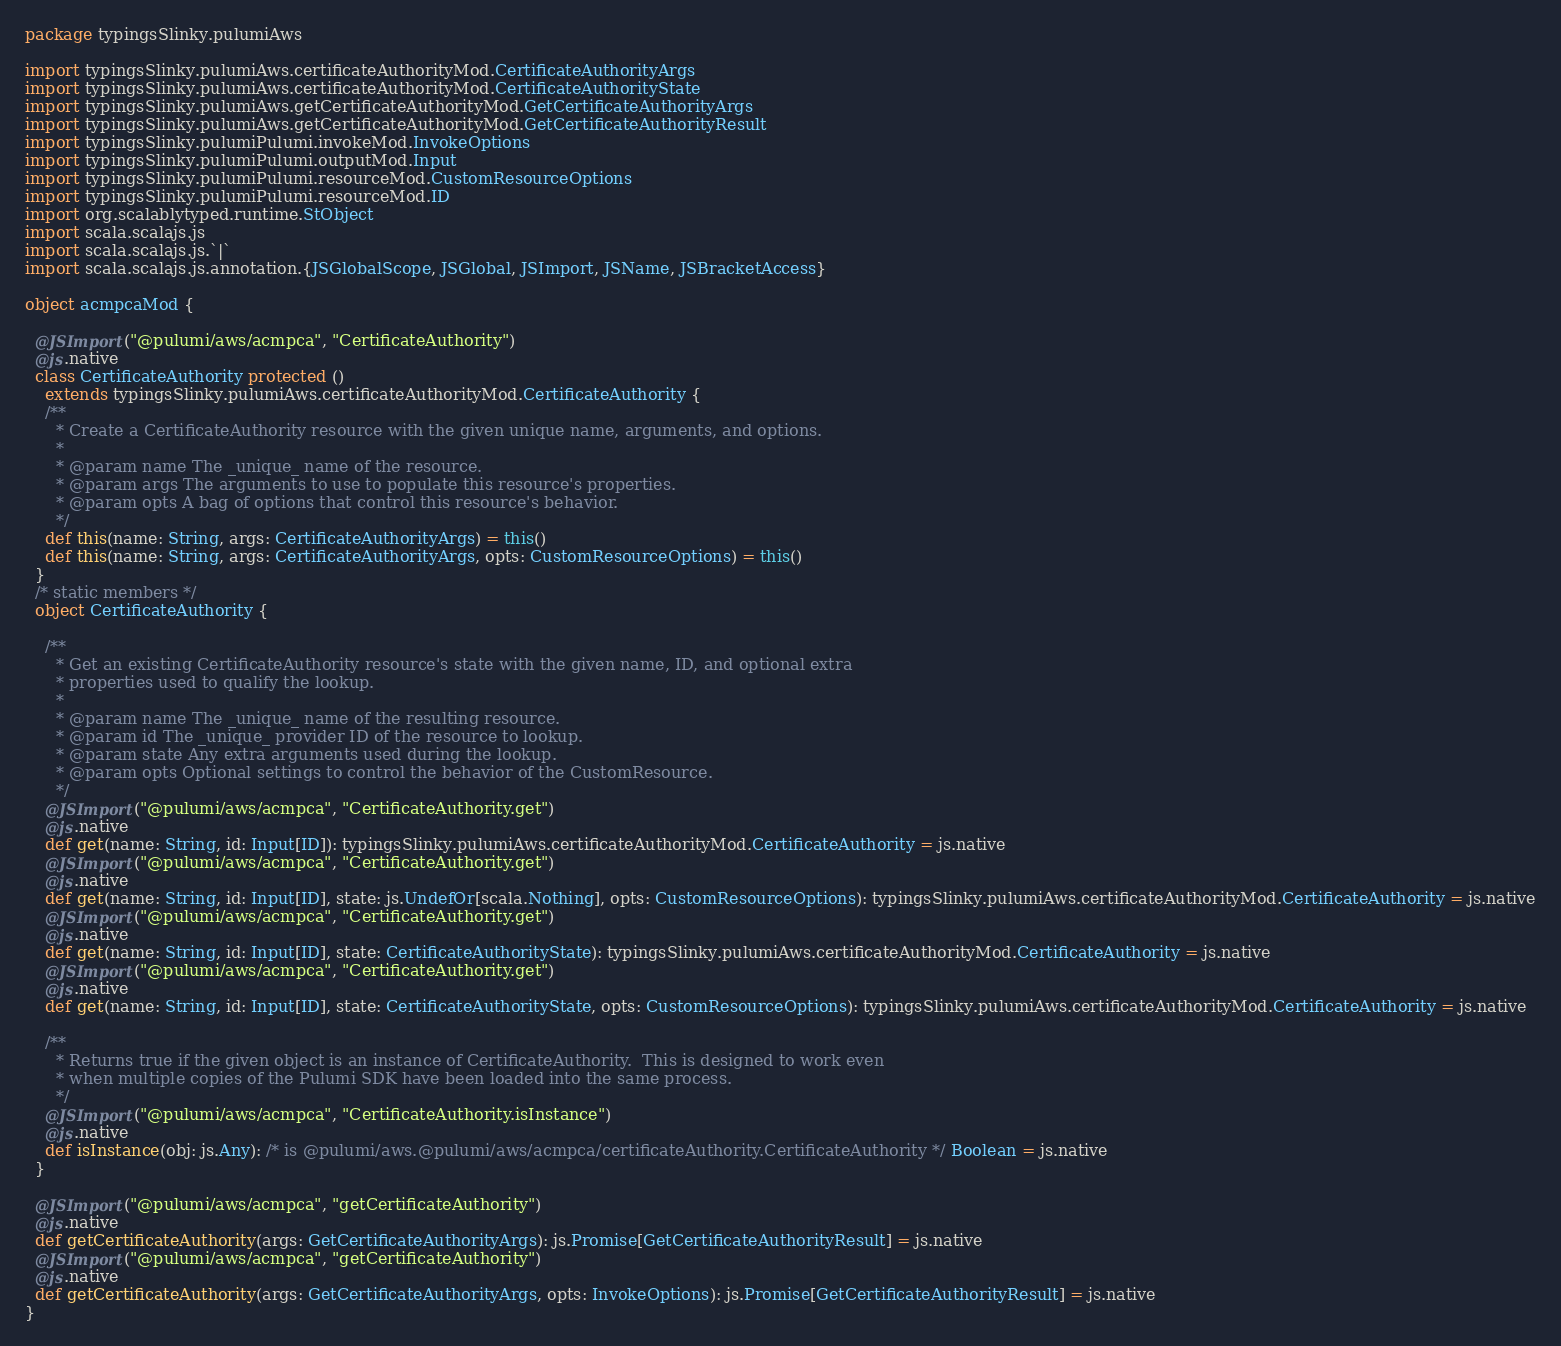Convert code to text. <code><loc_0><loc_0><loc_500><loc_500><_Scala_>package typingsSlinky.pulumiAws

import typingsSlinky.pulumiAws.certificateAuthorityMod.CertificateAuthorityArgs
import typingsSlinky.pulumiAws.certificateAuthorityMod.CertificateAuthorityState
import typingsSlinky.pulumiAws.getCertificateAuthorityMod.GetCertificateAuthorityArgs
import typingsSlinky.pulumiAws.getCertificateAuthorityMod.GetCertificateAuthorityResult
import typingsSlinky.pulumiPulumi.invokeMod.InvokeOptions
import typingsSlinky.pulumiPulumi.outputMod.Input
import typingsSlinky.pulumiPulumi.resourceMod.CustomResourceOptions
import typingsSlinky.pulumiPulumi.resourceMod.ID
import org.scalablytyped.runtime.StObject
import scala.scalajs.js
import scala.scalajs.js.`|`
import scala.scalajs.js.annotation.{JSGlobalScope, JSGlobal, JSImport, JSName, JSBracketAccess}

object acmpcaMod {
  
  @JSImport("@pulumi/aws/acmpca", "CertificateAuthority")
  @js.native
  class CertificateAuthority protected ()
    extends typingsSlinky.pulumiAws.certificateAuthorityMod.CertificateAuthority {
    /**
      * Create a CertificateAuthority resource with the given unique name, arguments, and options.
      *
      * @param name The _unique_ name of the resource.
      * @param args The arguments to use to populate this resource's properties.
      * @param opts A bag of options that control this resource's behavior.
      */
    def this(name: String, args: CertificateAuthorityArgs) = this()
    def this(name: String, args: CertificateAuthorityArgs, opts: CustomResourceOptions) = this()
  }
  /* static members */
  object CertificateAuthority {
    
    /**
      * Get an existing CertificateAuthority resource's state with the given name, ID, and optional extra
      * properties used to qualify the lookup.
      *
      * @param name The _unique_ name of the resulting resource.
      * @param id The _unique_ provider ID of the resource to lookup.
      * @param state Any extra arguments used during the lookup.
      * @param opts Optional settings to control the behavior of the CustomResource.
      */
    @JSImport("@pulumi/aws/acmpca", "CertificateAuthority.get")
    @js.native
    def get(name: String, id: Input[ID]): typingsSlinky.pulumiAws.certificateAuthorityMod.CertificateAuthority = js.native
    @JSImport("@pulumi/aws/acmpca", "CertificateAuthority.get")
    @js.native
    def get(name: String, id: Input[ID], state: js.UndefOr[scala.Nothing], opts: CustomResourceOptions): typingsSlinky.pulumiAws.certificateAuthorityMod.CertificateAuthority = js.native
    @JSImport("@pulumi/aws/acmpca", "CertificateAuthority.get")
    @js.native
    def get(name: String, id: Input[ID], state: CertificateAuthorityState): typingsSlinky.pulumiAws.certificateAuthorityMod.CertificateAuthority = js.native
    @JSImport("@pulumi/aws/acmpca", "CertificateAuthority.get")
    @js.native
    def get(name: String, id: Input[ID], state: CertificateAuthorityState, opts: CustomResourceOptions): typingsSlinky.pulumiAws.certificateAuthorityMod.CertificateAuthority = js.native
    
    /**
      * Returns true if the given object is an instance of CertificateAuthority.  This is designed to work even
      * when multiple copies of the Pulumi SDK have been loaded into the same process.
      */
    @JSImport("@pulumi/aws/acmpca", "CertificateAuthority.isInstance")
    @js.native
    def isInstance(obj: js.Any): /* is @pulumi/aws.@pulumi/aws/acmpca/certificateAuthority.CertificateAuthority */ Boolean = js.native
  }
  
  @JSImport("@pulumi/aws/acmpca", "getCertificateAuthority")
  @js.native
  def getCertificateAuthority(args: GetCertificateAuthorityArgs): js.Promise[GetCertificateAuthorityResult] = js.native
  @JSImport("@pulumi/aws/acmpca", "getCertificateAuthority")
  @js.native
  def getCertificateAuthority(args: GetCertificateAuthorityArgs, opts: InvokeOptions): js.Promise[GetCertificateAuthorityResult] = js.native
}
</code> 